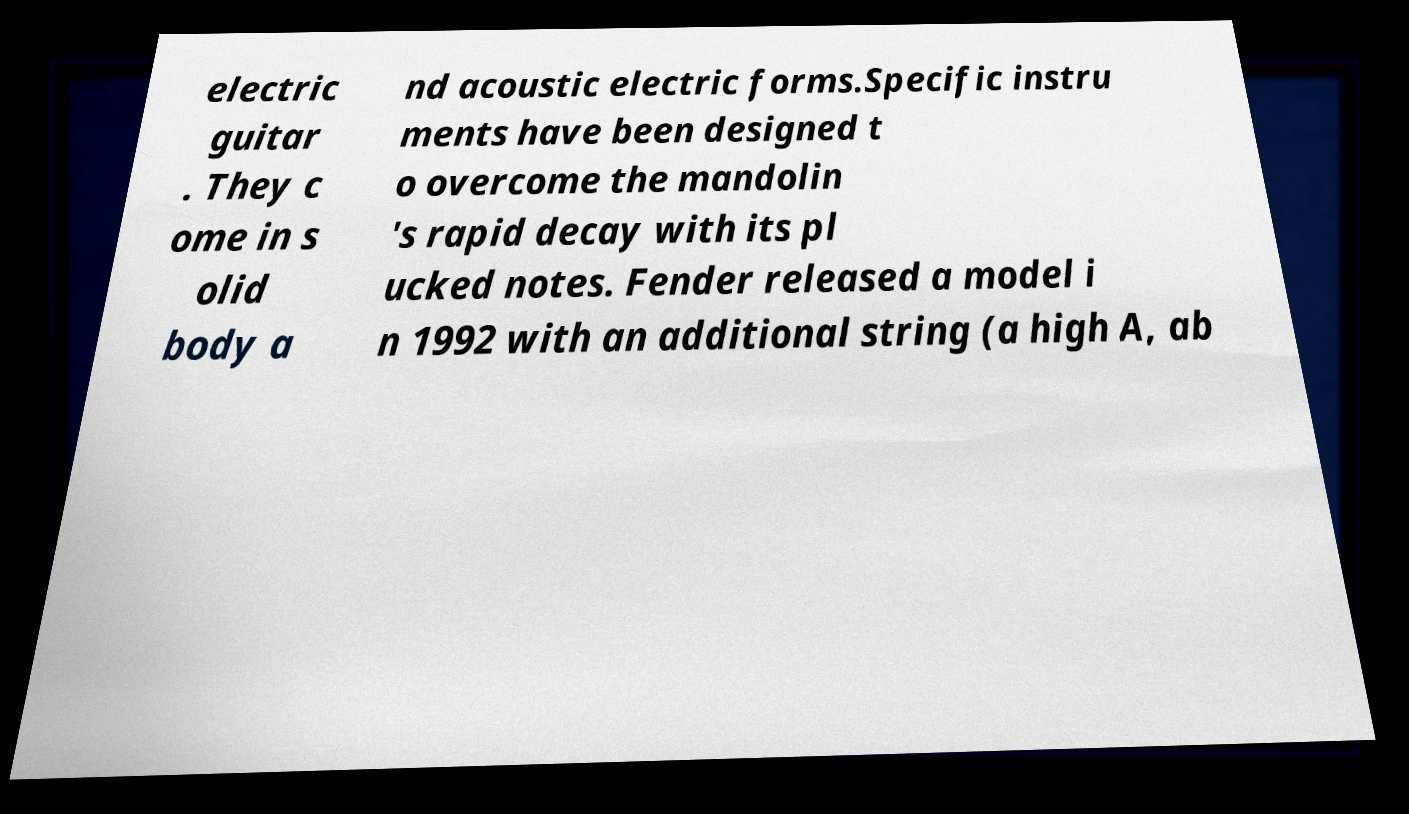What messages or text are displayed in this image? I need them in a readable, typed format. electric guitar . They c ome in s olid body a nd acoustic electric forms.Specific instru ments have been designed t o overcome the mandolin 's rapid decay with its pl ucked notes. Fender released a model i n 1992 with an additional string (a high A, ab 